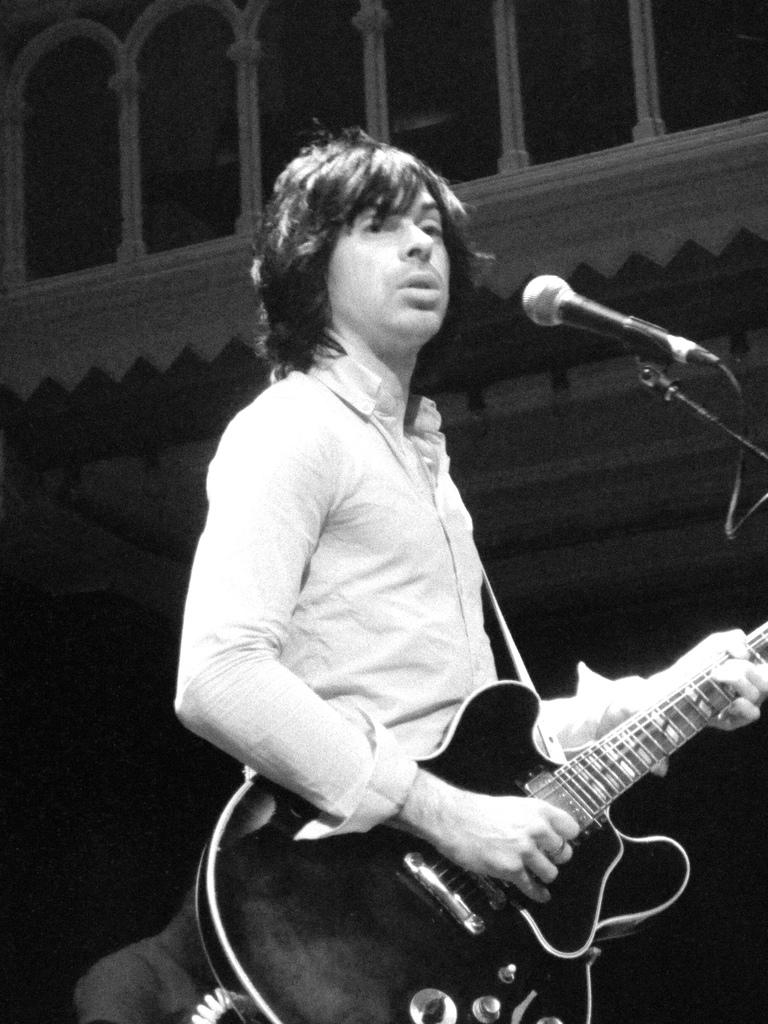What is the man in the image holding? The man is holding a guitar. What is the man doing with the guitar? The man is playing the guitar. What object is in front of the man? There is a microphone in front of the man. What type of arch can be seen in the background of the image? There is no arch present in the image. What is the value of the coal in the image? There is no coal present in the image. 